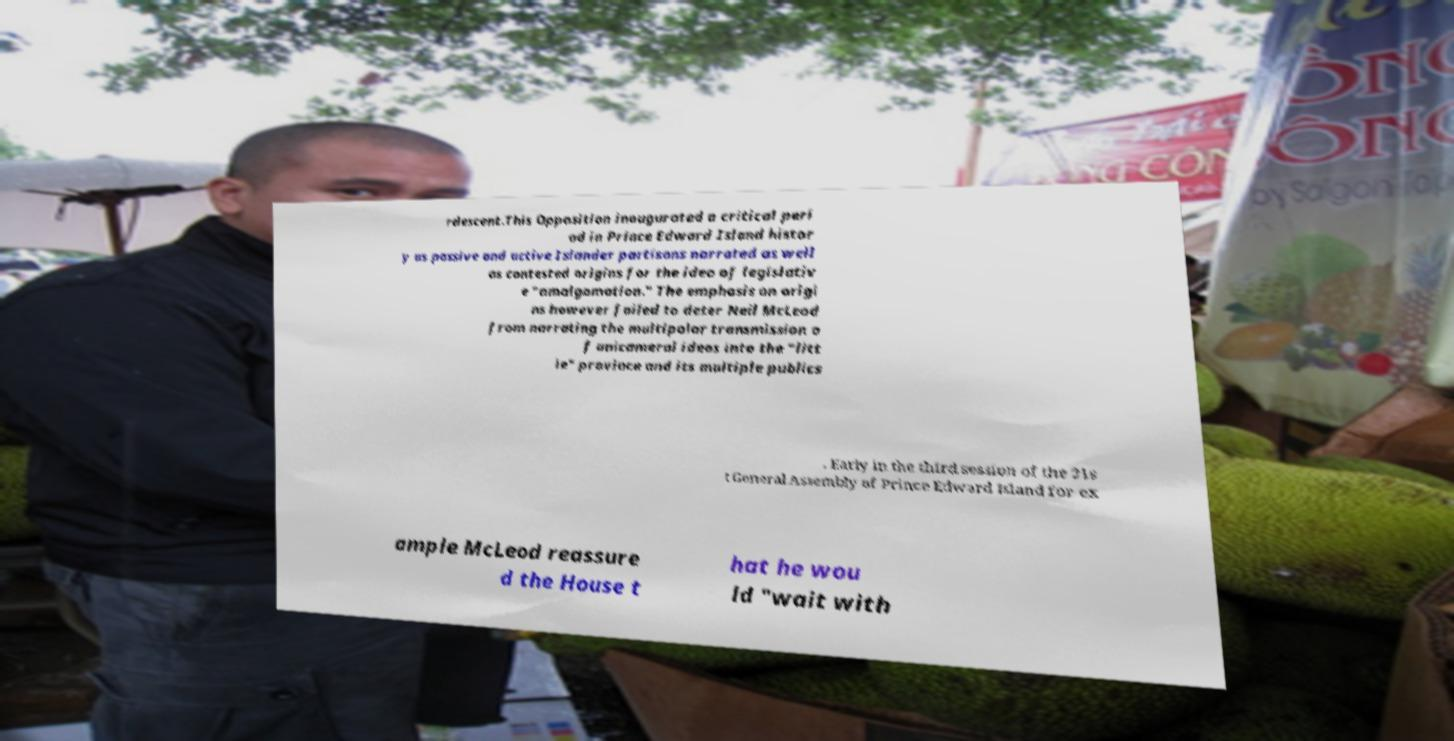I need the written content from this picture converted into text. Can you do that? rdescent.This Opposition inaugurated a critical peri od in Prince Edward Island histor y as passive and active Islander partisans narrated as well as contested origins for the idea of legislativ e "amalgamation." The emphasis on origi ns however failed to deter Neil McLeod from narrating the multipolar transmission o f unicameral ideas into the "litt le" province and its multiple publics . Early in the third session of the 31s t General Assembly of Prince Edward Island for ex ample McLeod reassure d the House t hat he wou ld "wait with 